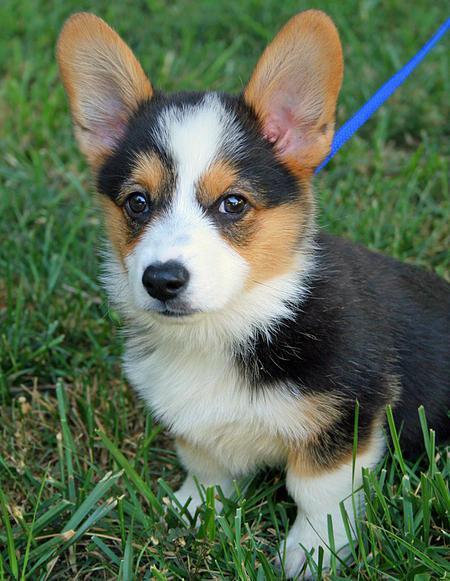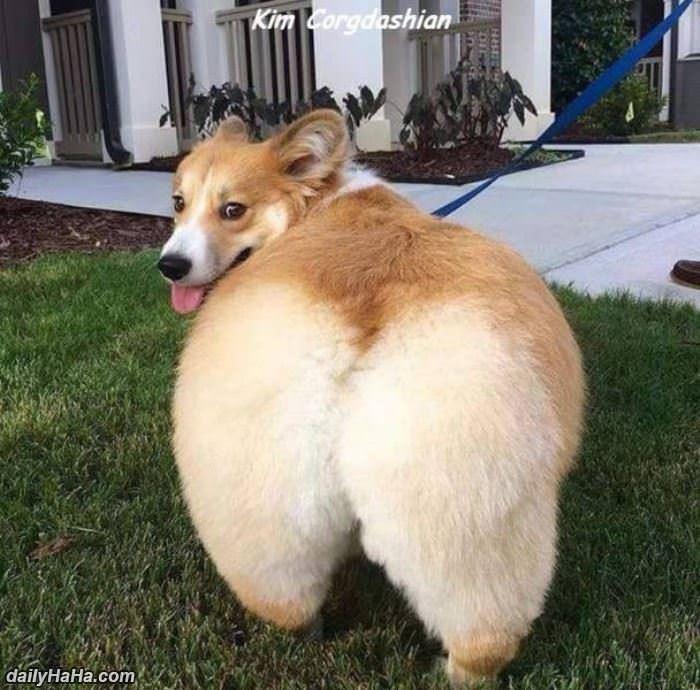The first image is the image on the left, the second image is the image on the right. For the images displayed, is the sentence "In the right image, a corgi's body is facing right while it's face is towards the camera." factually correct? Answer yes or no. No. The first image is the image on the left, the second image is the image on the right. For the images shown, is this caption "The left image features a camera-gazing corgi with its tongue hanging out, and the right image shows a corgi standing rightward in profile, with its head turned forward." true? Answer yes or no. No. 